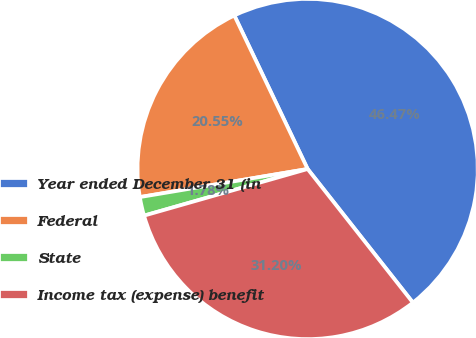Convert chart. <chart><loc_0><loc_0><loc_500><loc_500><pie_chart><fcel>Year ended December 31 (in<fcel>Federal<fcel>State<fcel>Income tax (expense) benefit<nl><fcel>46.47%<fcel>20.55%<fcel>1.78%<fcel>31.2%<nl></chart> 